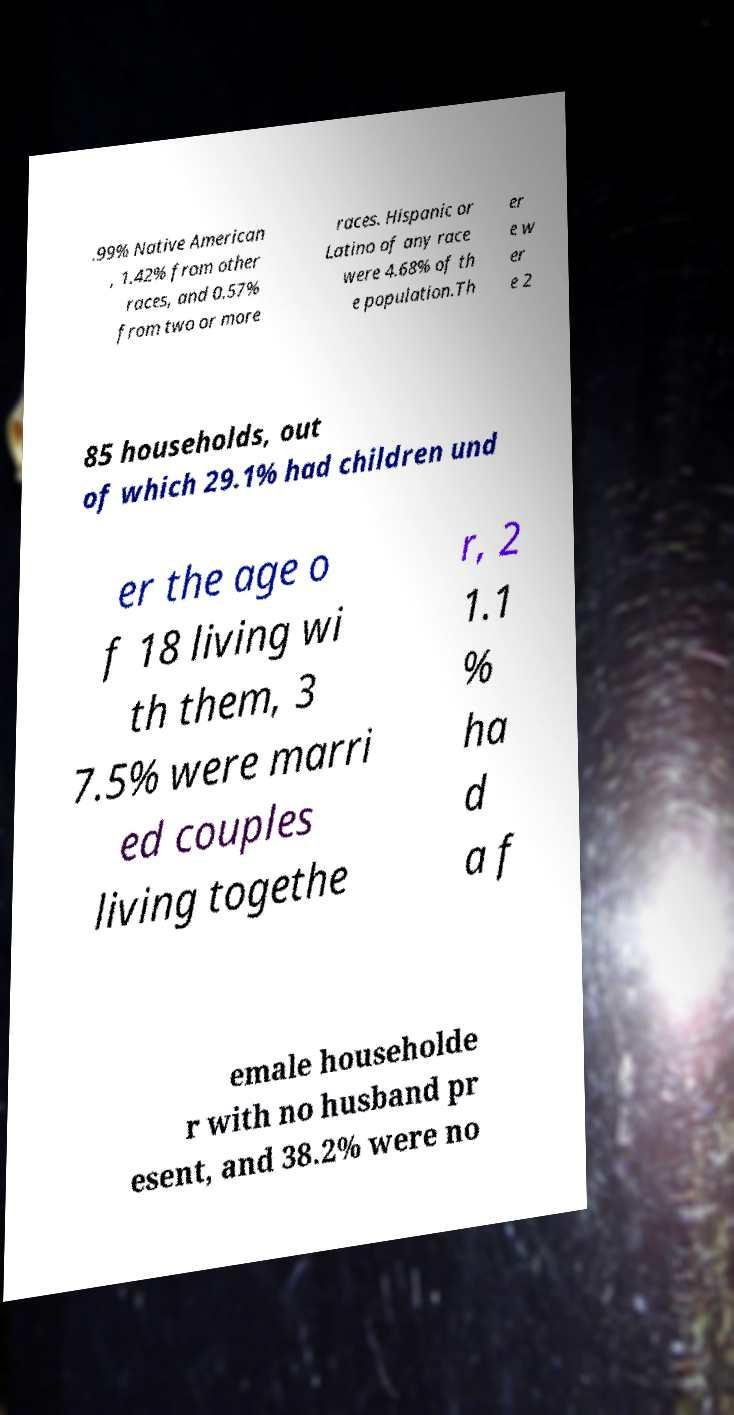For documentation purposes, I need the text within this image transcribed. Could you provide that? .99% Native American , 1.42% from other races, and 0.57% from two or more races. Hispanic or Latino of any race were 4.68% of th e population.Th er e w er e 2 85 households, out of which 29.1% had children und er the age o f 18 living wi th them, 3 7.5% were marri ed couples living togethe r, 2 1.1 % ha d a f emale householde r with no husband pr esent, and 38.2% were no 